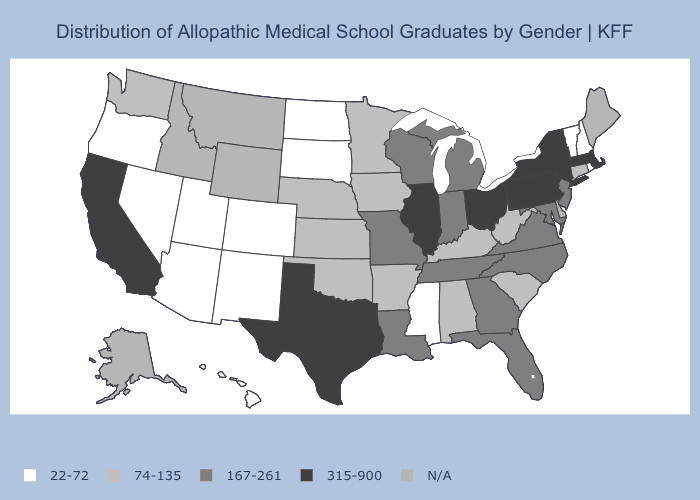What is the value of Nevada?
Short answer required. 22-72. What is the lowest value in states that border North Dakota?
Write a very short answer. 22-72. Does the map have missing data?
Answer briefly. Yes. Which states have the highest value in the USA?
Be succinct. California, Illinois, Massachusetts, New York, Ohio, Pennsylvania, Texas. Which states have the highest value in the USA?
Quick response, please. California, Illinois, Massachusetts, New York, Ohio, Pennsylvania, Texas. Which states have the lowest value in the USA?
Concise answer only. Arizona, Colorado, Hawaii, Mississippi, Nevada, New Hampshire, New Mexico, North Dakota, Oregon, Rhode Island, South Dakota, Utah, Vermont. What is the value of West Virginia?
Give a very brief answer. 74-135. What is the lowest value in the USA?
Quick response, please. 22-72. What is the lowest value in the West?
Keep it brief. 22-72. Name the states that have a value in the range 167-261?
Concise answer only. Florida, Georgia, Indiana, Louisiana, Maryland, Michigan, Missouri, New Jersey, North Carolina, Tennessee, Virginia, Wisconsin. Among the states that border Oklahoma , which have the lowest value?
Give a very brief answer. Colorado, New Mexico. What is the value of Arkansas?
Be succinct. 74-135. What is the value of Kansas?
Quick response, please. 74-135. What is the highest value in states that border Michigan?
Short answer required. 315-900. 